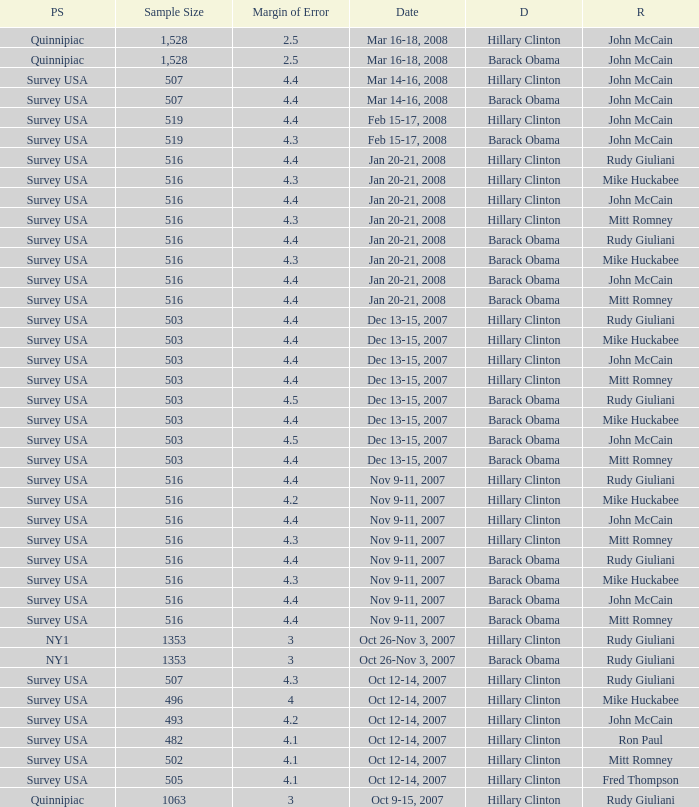Write the full table. {'header': ['PS', 'Sample Size', 'Margin of Error', 'Date', 'D', 'R'], 'rows': [['Quinnipiac', '1,528', '2.5', 'Mar 16-18, 2008', 'Hillary Clinton', 'John McCain'], ['Quinnipiac', '1,528', '2.5', 'Mar 16-18, 2008', 'Barack Obama', 'John McCain'], ['Survey USA', '507', '4.4', 'Mar 14-16, 2008', 'Hillary Clinton', 'John McCain'], ['Survey USA', '507', '4.4', 'Mar 14-16, 2008', 'Barack Obama', 'John McCain'], ['Survey USA', '519', '4.4', 'Feb 15-17, 2008', 'Hillary Clinton', 'John McCain'], ['Survey USA', '519', '4.3', 'Feb 15-17, 2008', 'Barack Obama', 'John McCain'], ['Survey USA', '516', '4.4', 'Jan 20-21, 2008', 'Hillary Clinton', 'Rudy Giuliani'], ['Survey USA', '516', '4.3', 'Jan 20-21, 2008', 'Hillary Clinton', 'Mike Huckabee'], ['Survey USA', '516', '4.4', 'Jan 20-21, 2008', 'Hillary Clinton', 'John McCain'], ['Survey USA', '516', '4.3', 'Jan 20-21, 2008', 'Hillary Clinton', 'Mitt Romney'], ['Survey USA', '516', '4.4', 'Jan 20-21, 2008', 'Barack Obama', 'Rudy Giuliani'], ['Survey USA', '516', '4.3', 'Jan 20-21, 2008', 'Barack Obama', 'Mike Huckabee'], ['Survey USA', '516', '4.4', 'Jan 20-21, 2008', 'Barack Obama', 'John McCain'], ['Survey USA', '516', '4.4', 'Jan 20-21, 2008', 'Barack Obama', 'Mitt Romney'], ['Survey USA', '503', '4.4', 'Dec 13-15, 2007', 'Hillary Clinton', 'Rudy Giuliani'], ['Survey USA', '503', '4.4', 'Dec 13-15, 2007', 'Hillary Clinton', 'Mike Huckabee'], ['Survey USA', '503', '4.4', 'Dec 13-15, 2007', 'Hillary Clinton', 'John McCain'], ['Survey USA', '503', '4.4', 'Dec 13-15, 2007', 'Hillary Clinton', 'Mitt Romney'], ['Survey USA', '503', '4.5', 'Dec 13-15, 2007', 'Barack Obama', 'Rudy Giuliani'], ['Survey USA', '503', '4.4', 'Dec 13-15, 2007', 'Barack Obama', 'Mike Huckabee'], ['Survey USA', '503', '4.5', 'Dec 13-15, 2007', 'Barack Obama', 'John McCain'], ['Survey USA', '503', '4.4', 'Dec 13-15, 2007', 'Barack Obama', 'Mitt Romney'], ['Survey USA', '516', '4.4', 'Nov 9-11, 2007', 'Hillary Clinton', 'Rudy Giuliani'], ['Survey USA', '516', '4.2', 'Nov 9-11, 2007', 'Hillary Clinton', 'Mike Huckabee'], ['Survey USA', '516', '4.4', 'Nov 9-11, 2007', 'Hillary Clinton', 'John McCain'], ['Survey USA', '516', '4.3', 'Nov 9-11, 2007', 'Hillary Clinton', 'Mitt Romney'], ['Survey USA', '516', '4.4', 'Nov 9-11, 2007', 'Barack Obama', 'Rudy Giuliani'], ['Survey USA', '516', '4.3', 'Nov 9-11, 2007', 'Barack Obama', 'Mike Huckabee'], ['Survey USA', '516', '4.4', 'Nov 9-11, 2007', 'Barack Obama', 'John McCain'], ['Survey USA', '516', '4.4', 'Nov 9-11, 2007', 'Barack Obama', 'Mitt Romney'], ['NY1', '1353', '3', 'Oct 26-Nov 3, 2007', 'Hillary Clinton', 'Rudy Giuliani'], ['NY1', '1353', '3', 'Oct 26-Nov 3, 2007', 'Barack Obama', 'Rudy Giuliani'], ['Survey USA', '507', '4.3', 'Oct 12-14, 2007', 'Hillary Clinton', 'Rudy Giuliani'], ['Survey USA', '496', '4', 'Oct 12-14, 2007', 'Hillary Clinton', 'Mike Huckabee'], ['Survey USA', '493', '4.2', 'Oct 12-14, 2007', 'Hillary Clinton', 'John McCain'], ['Survey USA', '482', '4.1', 'Oct 12-14, 2007', 'Hillary Clinton', 'Ron Paul'], ['Survey USA', '502', '4.1', 'Oct 12-14, 2007', 'Hillary Clinton', 'Mitt Romney'], ['Survey USA', '505', '4.1', 'Oct 12-14, 2007', 'Hillary Clinton', 'Fred Thompson'], ['Quinnipiac', '1063', '3', 'Oct 9-15, 2007', 'Hillary Clinton', 'Rudy Giuliani']]} What was the date of the poll with a sample size of 496 where Republican Mike Huckabee was chosen? Oct 12-14, 2007. 